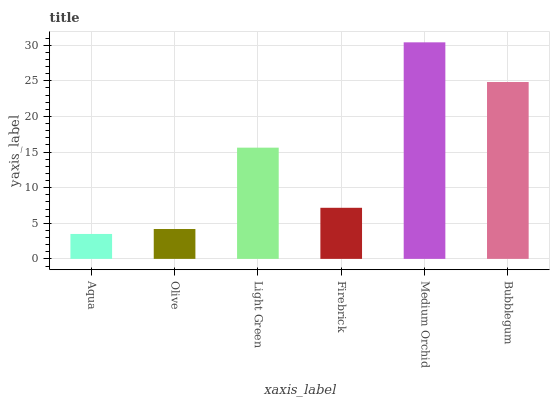Is Aqua the minimum?
Answer yes or no. Yes. Is Medium Orchid the maximum?
Answer yes or no. Yes. Is Olive the minimum?
Answer yes or no. No. Is Olive the maximum?
Answer yes or no. No. Is Olive greater than Aqua?
Answer yes or no. Yes. Is Aqua less than Olive?
Answer yes or no. Yes. Is Aqua greater than Olive?
Answer yes or no. No. Is Olive less than Aqua?
Answer yes or no. No. Is Light Green the high median?
Answer yes or no. Yes. Is Firebrick the low median?
Answer yes or no. Yes. Is Firebrick the high median?
Answer yes or no. No. Is Light Green the low median?
Answer yes or no. No. 